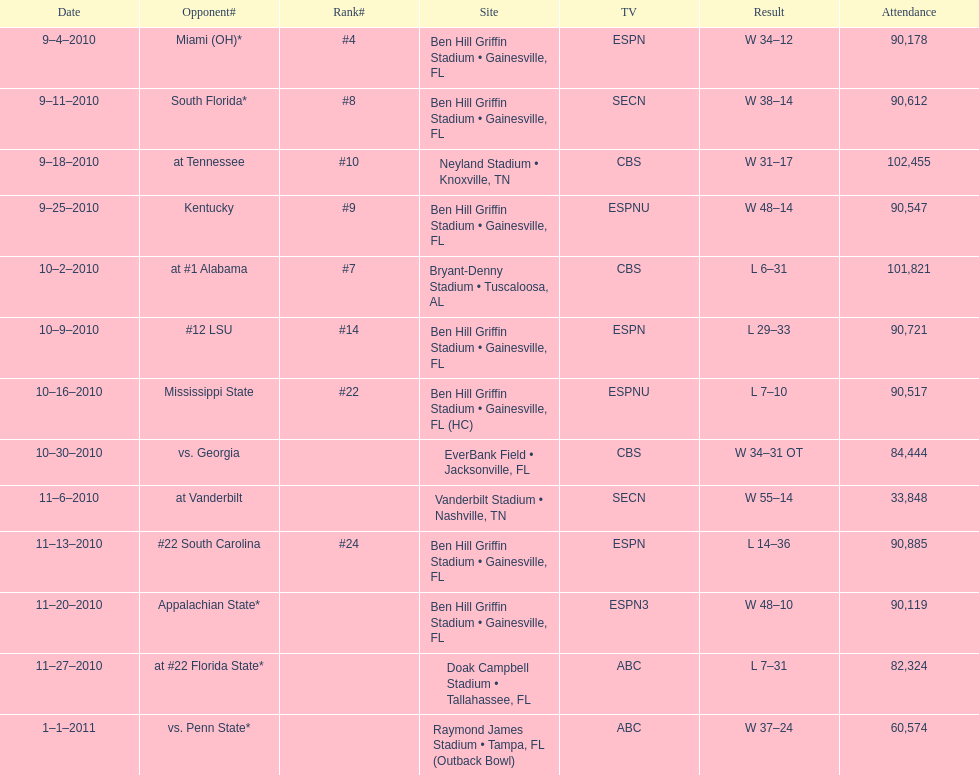Who emerged as the winner in the prior game? Gators. 